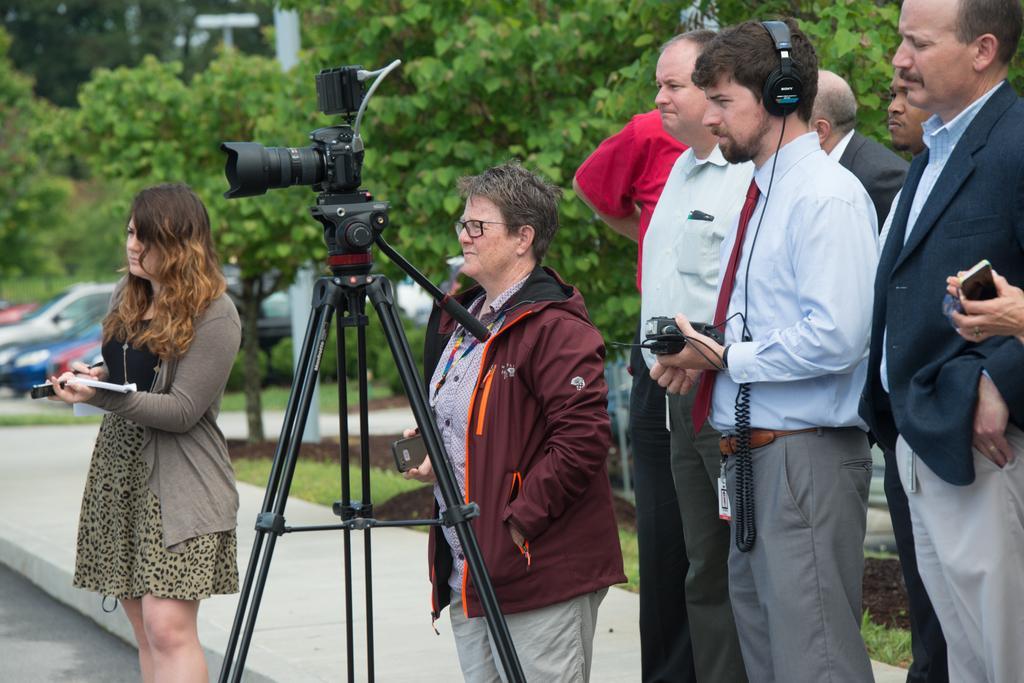Please provide a concise description of this image. This image consists of few persons. In the middle, there is a camera along with camera stand. At the bottom, there is a road and pavement. In the background, we can see the cars parked. And there are plants along with green grass on the ground. 